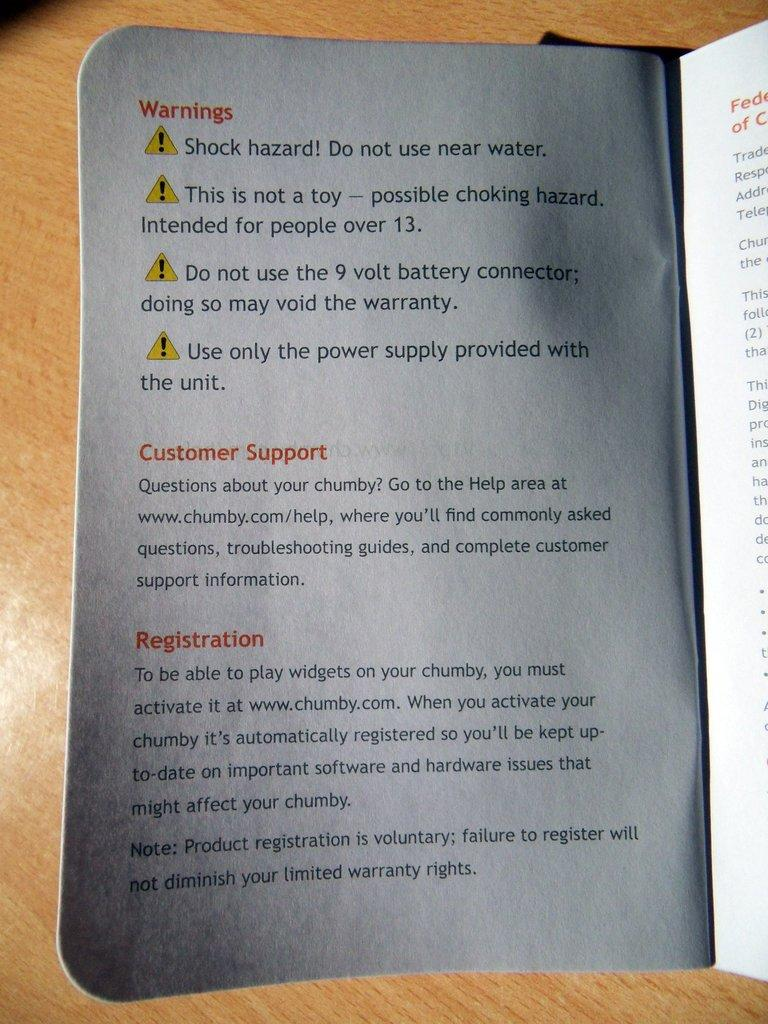<image>
Create a compact narrative representing the image presented. A white warning label about shock hazard potential. 